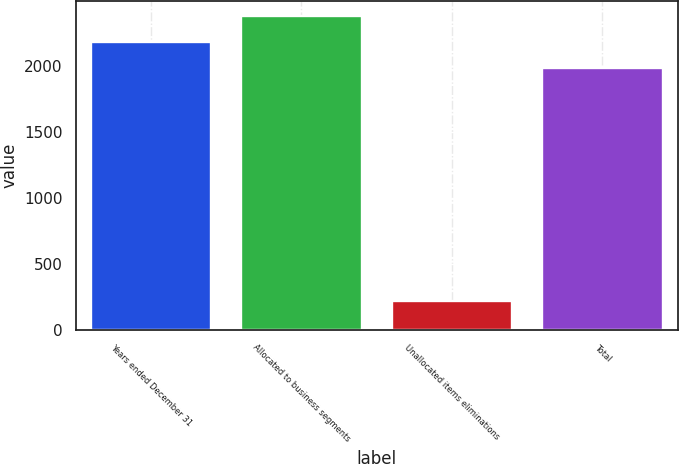<chart> <loc_0><loc_0><loc_500><loc_500><bar_chart><fcel>Years ended December 31<fcel>Allocated to business segments<fcel>Unallocated items eliminations<fcel>Total<nl><fcel>2176.9<fcel>2374.8<fcel>217<fcel>1979<nl></chart> 